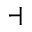Convert formula to latex. <formula><loc_0><loc_0><loc_500><loc_500>\dashv</formula> 